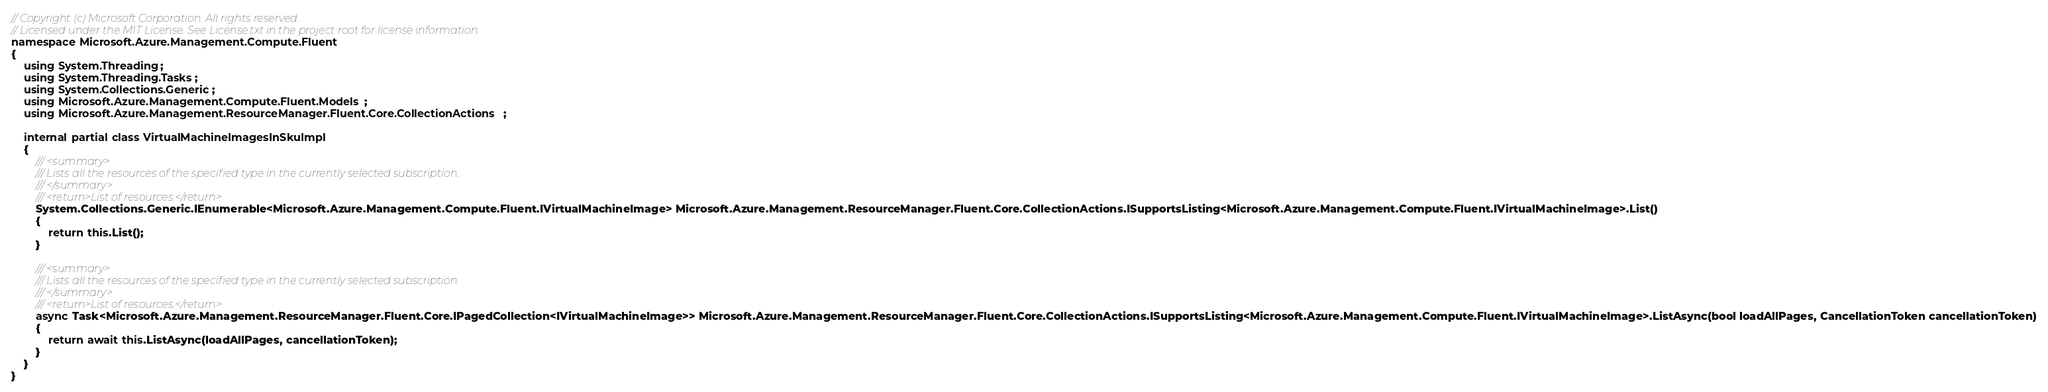Convert code to text. <code><loc_0><loc_0><loc_500><loc_500><_C#_>// Copyright (c) Microsoft Corporation. All rights reserved.
// Licensed under the MIT License. See License.txt in the project root for license information.
namespace Microsoft.Azure.Management.Compute.Fluent
{
    using System.Threading;
    using System.Threading.Tasks;
    using System.Collections.Generic;
    using Microsoft.Azure.Management.Compute.Fluent.Models;
    using Microsoft.Azure.Management.ResourceManager.Fluent.Core.CollectionActions;

    internal partial class VirtualMachineImagesInSkuImpl
    {
        /// <summary>
        /// Lists all the resources of the specified type in the currently selected subscription.
        /// </summary>
        /// <return>List of resources.</return>
        System.Collections.Generic.IEnumerable<Microsoft.Azure.Management.Compute.Fluent.IVirtualMachineImage> Microsoft.Azure.Management.ResourceManager.Fluent.Core.CollectionActions.ISupportsListing<Microsoft.Azure.Management.Compute.Fluent.IVirtualMachineImage>.List()
        {
            return this.List();
        }

        /// <summary>
        /// Lists all the resources of the specified type in the currently selected subscription.
        /// </summary>
        /// <return>List of resources.</return>
        async Task<Microsoft.Azure.Management.ResourceManager.Fluent.Core.IPagedCollection<IVirtualMachineImage>> Microsoft.Azure.Management.ResourceManager.Fluent.Core.CollectionActions.ISupportsListing<Microsoft.Azure.Management.Compute.Fluent.IVirtualMachineImage>.ListAsync(bool loadAllPages, CancellationToken cancellationToken)
        {
            return await this.ListAsync(loadAllPages, cancellationToken);
        }
    }
}</code> 